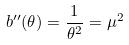Convert formula to latex. <formula><loc_0><loc_0><loc_500><loc_500>b ^ { \prime \prime } ( \theta ) = \frac { 1 } { \theta ^ { 2 } } = \mu ^ { 2 }</formula> 